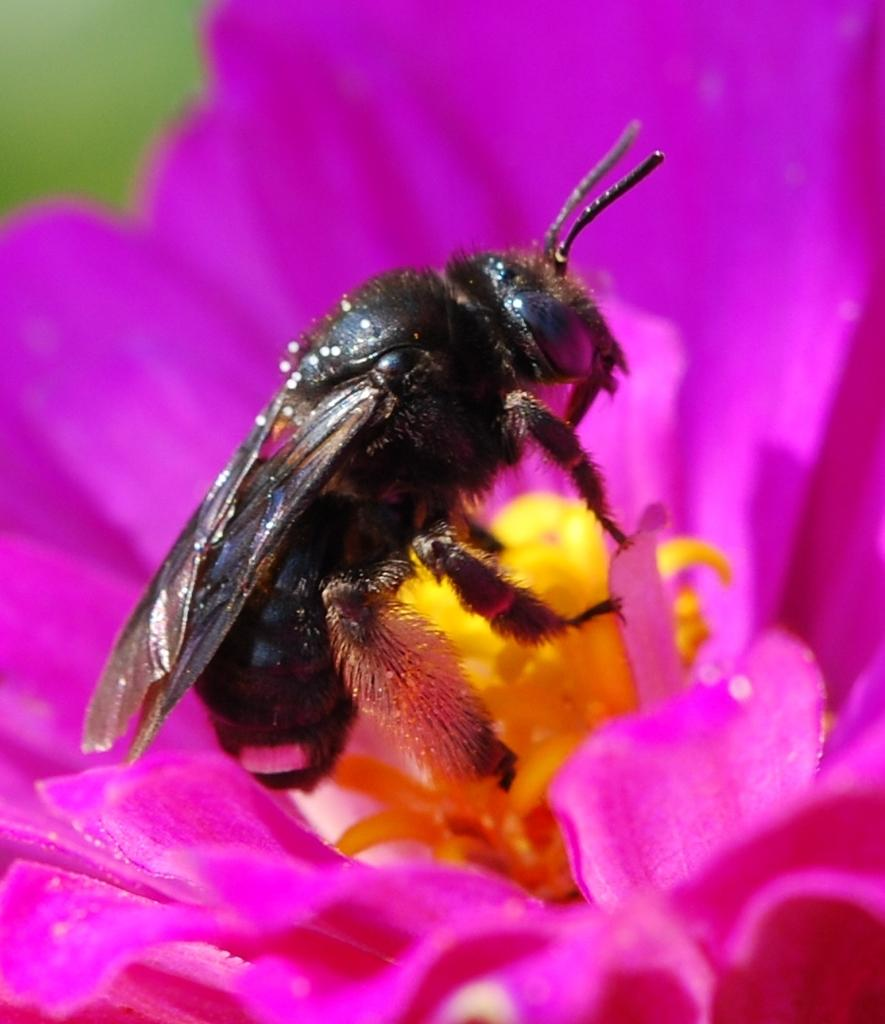What type of flower is present in the image? There is a pink colorful flower in the image. Is there any other living organism present on the flower? Yes, there is a honey bee sitting on the flower. What decision did the sister make regarding the flower in the image? There is no mention of a sister or any decision-making in the image. 